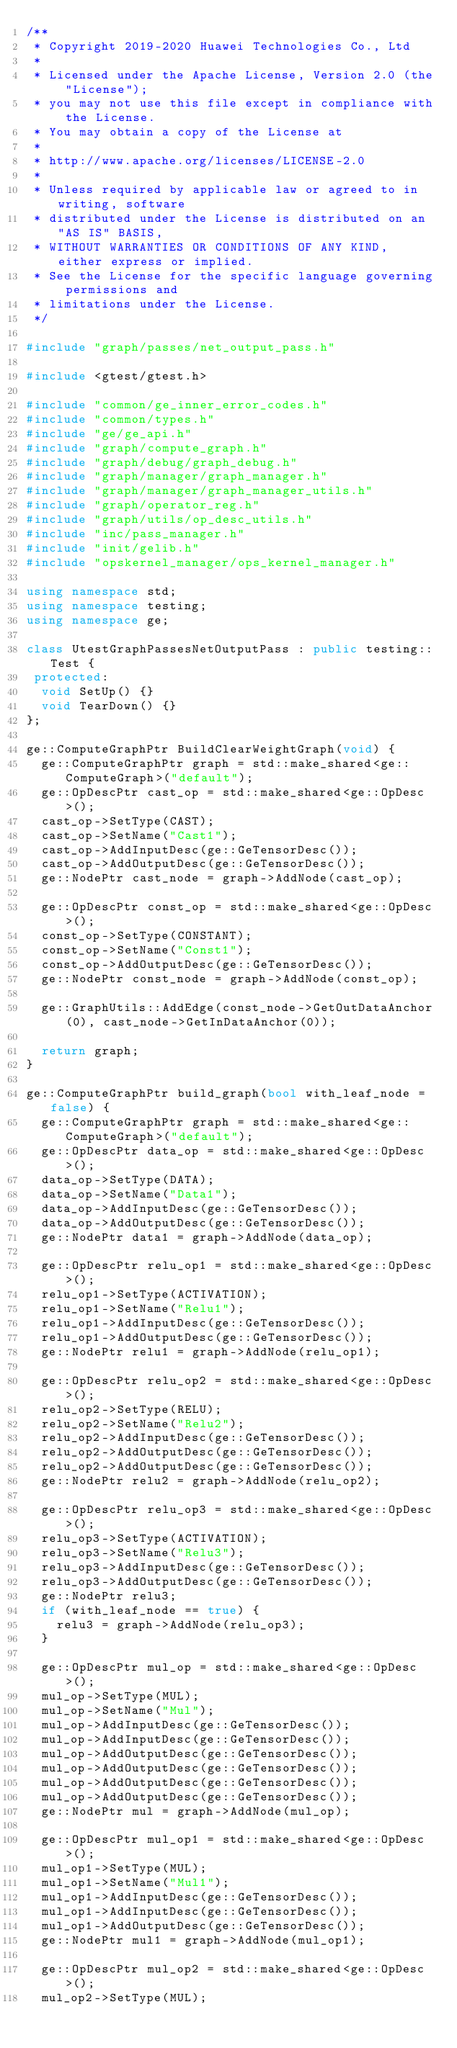Convert code to text. <code><loc_0><loc_0><loc_500><loc_500><_C++_>/**
 * Copyright 2019-2020 Huawei Technologies Co., Ltd
 *
 * Licensed under the Apache License, Version 2.0 (the "License");
 * you may not use this file except in compliance with the License.
 * You may obtain a copy of the License at
 *
 * http://www.apache.org/licenses/LICENSE-2.0
 *
 * Unless required by applicable law or agreed to in writing, software
 * distributed under the License is distributed on an "AS IS" BASIS,
 * WITHOUT WARRANTIES OR CONDITIONS OF ANY KIND, either express or implied.
 * See the License for the specific language governing permissions and
 * limitations under the License.
 */

#include "graph/passes/net_output_pass.h"

#include <gtest/gtest.h>

#include "common/ge_inner_error_codes.h"
#include "common/types.h"
#include "ge/ge_api.h"
#include "graph/compute_graph.h"
#include "graph/debug/graph_debug.h"
#include "graph/manager/graph_manager.h"
#include "graph/manager/graph_manager_utils.h"
#include "graph/operator_reg.h"
#include "graph/utils/op_desc_utils.h"
#include "inc/pass_manager.h"
#include "init/gelib.h"
#include "opskernel_manager/ops_kernel_manager.h"

using namespace std;
using namespace testing;
using namespace ge;

class UtestGraphPassesNetOutputPass : public testing::Test {
 protected:
  void SetUp() {}
  void TearDown() {}
};

ge::ComputeGraphPtr BuildClearWeightGraph(void) {
  ge::ComputeGraphPtr graph = std::make_shared<ge::ComputeGraph>("default");
  ge::OpDescPtr cast_op = std::make_shared<ge::OpDesc>();
  cast_op->SetType(CAST);
  cast_op->SetName("Cast1");
  cast_op->AddInputDesc(ge::GeTensorDesc());
  cast_op->AddOutputDesc(ge::GeTensorDesc());
  ge::NodePtr cast_node = graph->AddNode(cast_op);

  ge::OpDescPtr const_op = std::make_shared<ge::OpDesc>();
  const_op->SetType(CONSTANT);
  const_op->SetName("Const1");
  const_op->AddOutputDesc(ge::GeTensorDesc());
  ge::NodePtr const_node = graph->AddNode(const_op);

  ge::GraphUtils::AddEdge(const_node->GetOutDataAnchor(0), cast_node->GetInDataAnchor(0));

  return graph;
}

ge::ComputeGraphPtr build_graph(bool with_leaf_node = false) {
  ge::ComputeGraphPtr graph = std::make_shared<ge::ComputeGraph>("default");
  ge::OpDescPtr data_op = std::make_shared<ge::OpDesc>();
  data_op->SetType(DATA);
  data_op->SetName("Data1");
  data_op->AddInputDesc(ge::GeTensorDesc());
  data_op->AddOutputDesc(ge::GeTensorDesc());
  ge::NodePtr data1 = graph->AddNode(data_op);

  ge::OpDescPtr relu_op1 = std::make_shared<ge::OpDesc>();
  relu_op1->SetType(ACTIVATION);
  relu_op1->SetName("Relu1");
  relu_op1->AddInputDesc(ge::GeTensorDesc());
  relu_op1->AddOutputDesc(ge::GeTensorDesc());
  ge::NodePtr relu1 = graph->AddNode(relu_op1);

  ge::OpDescPtr relu_op2 = std::make_shared<ge::OpDesc>();
  relu_op2->SetType(RELU);
  relu_op2->SetName("Relu2");
  relu_op2->AddInputDesc(ge::GeTensorDesc());
  relu_op2->AddOutputDesc(ge::GeTensorDesc());
  relu_op2->AddOutputDesc(ge::GeTensorDesc());
  ge::NodePtr relu2 = graph->AddNode(relu_op2);

  ge::OpDescPtr relu_op3 = std::make_shared<ge::OpDesc>();
  relu_op3->SetType(ACTIVATION);
  relu_op3->SetName("Relu3");
  relu_op3->AddInputDesc(ge::GeTensorDesc());
  relu_op3->AddOutputDesc(ge::GeTensorDesc());
  ge::NodePtr relu3;
  if (with_leaf_node == true) {
    relu3 = graph->AddNode(relu_op3);
  }

  ge::OpDescPtr mul_op = std::make_shared<ge::OpDesc>();
  mul_op->SetType(MUL);
  mul_op->SetName("Mul");
  mul_op->AddInputDesc(ge::GeTensorDesc());
  mul_op->AddInputDesc(ge::GeTensorDesc());
  mul_op->AddOutputDesc(ge::GeTensorDesc());
  mul_op->AddOutputDesc(ge::GeTensorDesc());
  mul_op->AddOutputDesc(ge::GeTensorDesc());
  mul_op->AddOutputDesc(ge::GeTensorDesc());
  ge::NodePtr mul = graph->AddNode(mul_op);

  ge::OpDescPtr mul_op1 = std::make_shared<ge::OpDesc>();
  mul_op1->SetType(MUL);
  mul_op1->SetName("Mul1");
  mul_op1->AddInputDesc(ge::GeTensorDesc());
  mul_op1->AddInputDesc(ge::GeTensorDesc());
  mul_op1->AddOutputDesc(ge::GeTensorDesc());
  ge::NodePtr mul1 = graph->AddNode(mul_op1);

  ge::OpDescPtr mul_op2 = std::make_shared<ge::OpDesc>();
  mul_op2->SetType(MUL);</code> 